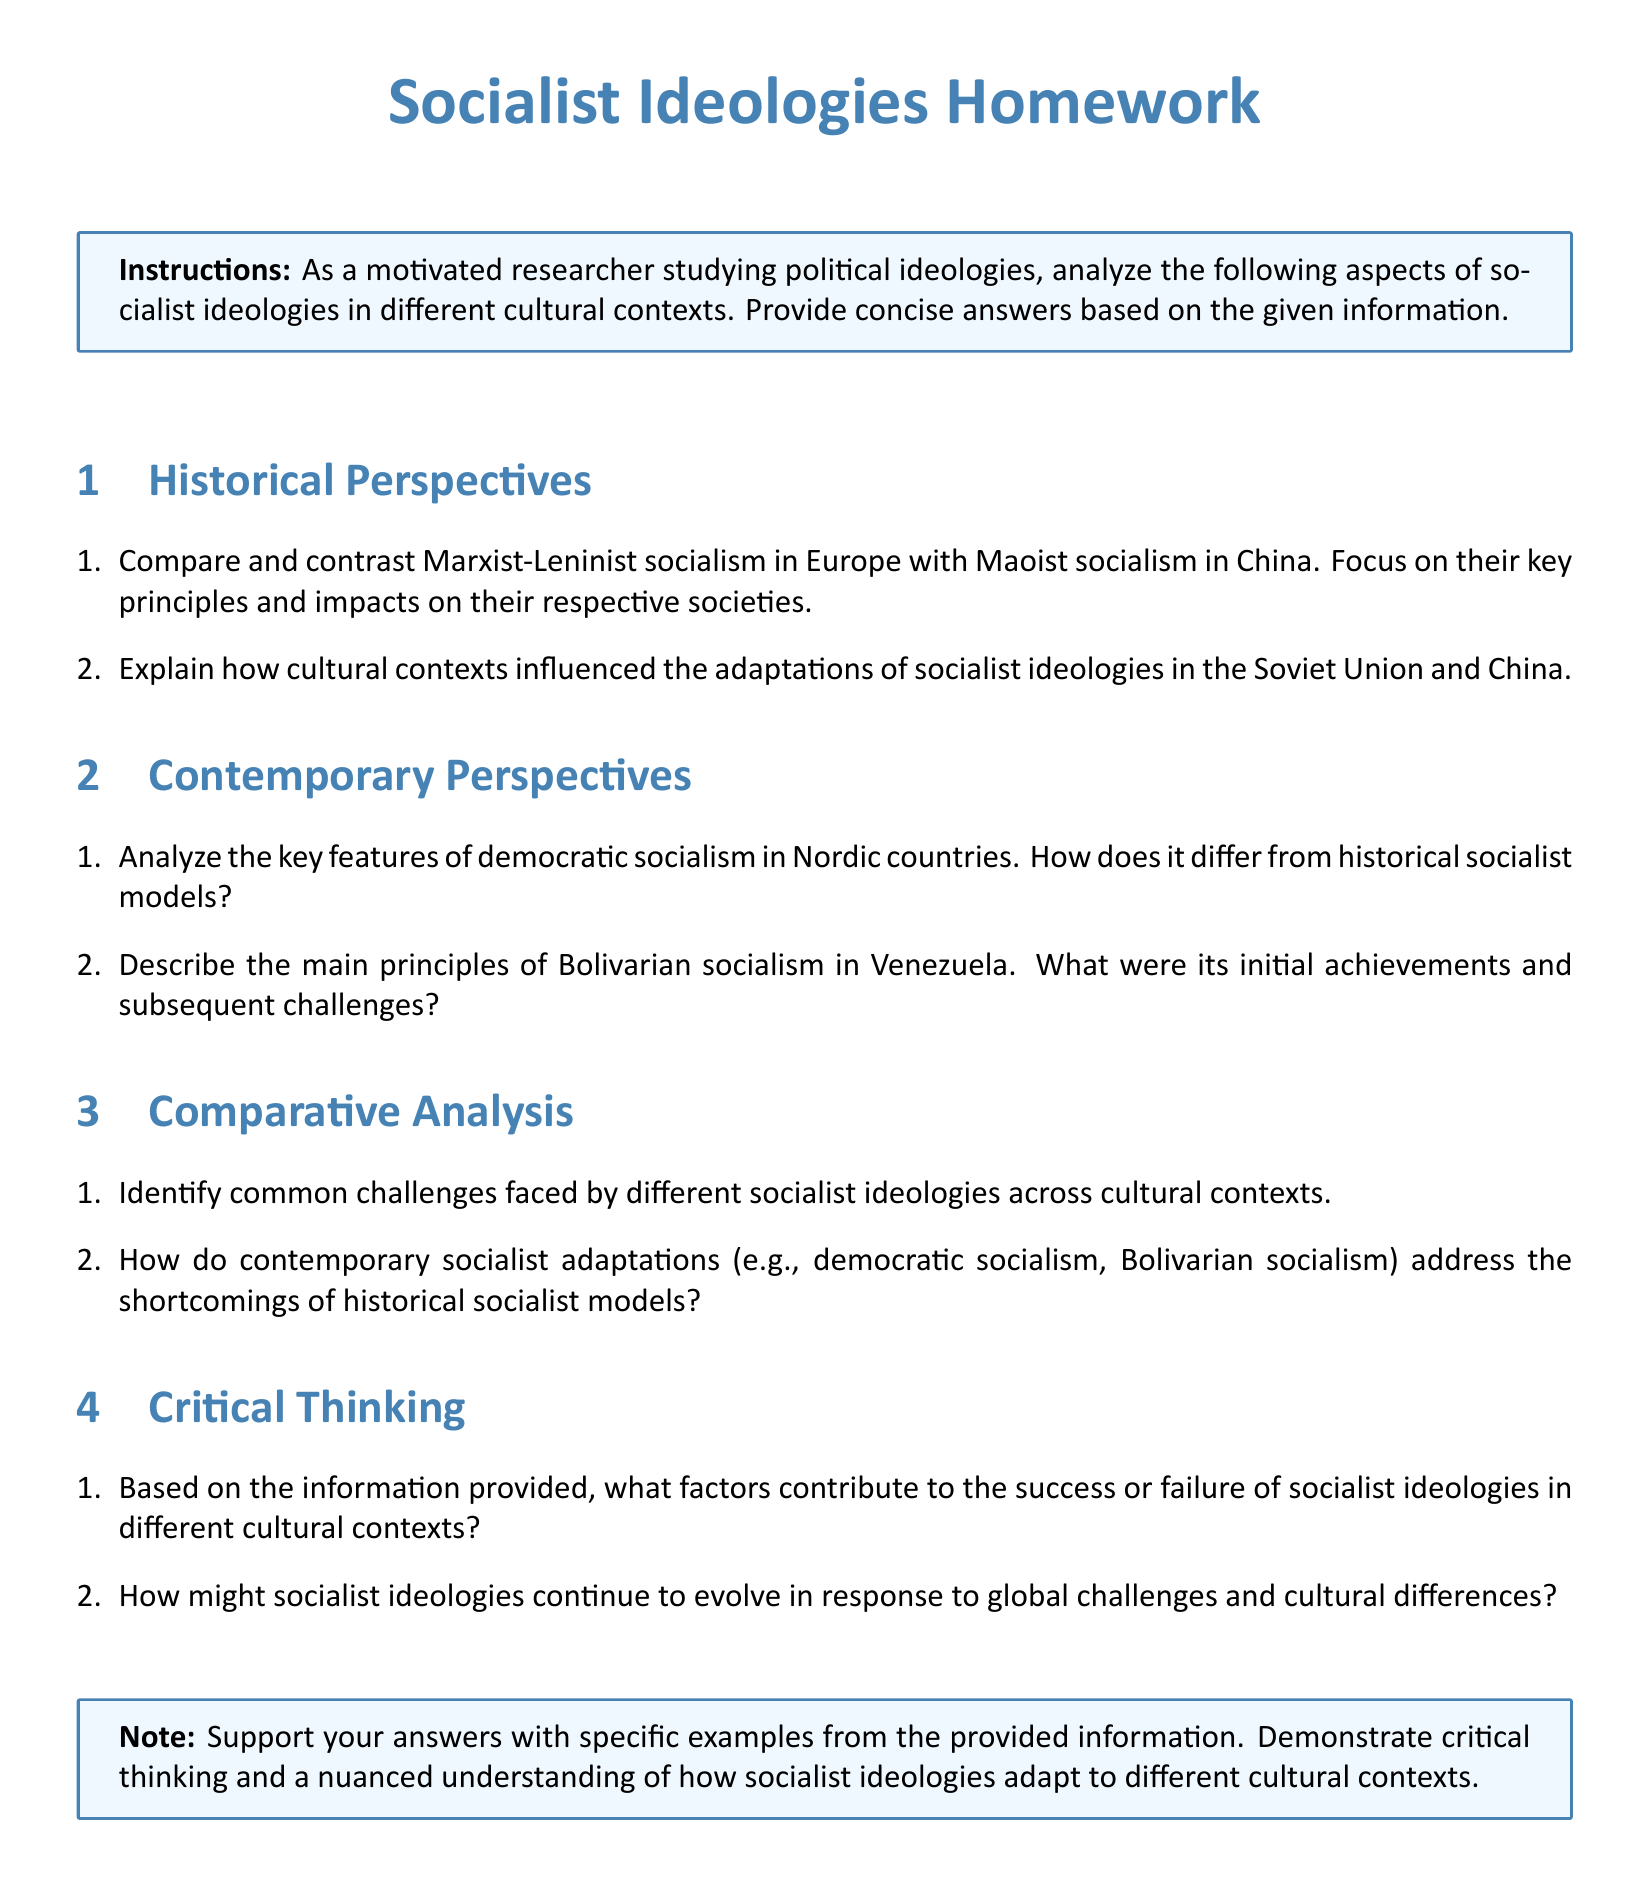What is the title of the homework? The title of the homework is presented at the top of the document.
Answer: Socialist Ideologies Homework How many sections are in the document? The document is organized into sections that are numbered.
Answer: Four What is the focus of the first question in the Historical Perspectives section? The first question asks for a comparison between two forms of socialism, which is detailed in the section.
Answer: Compare and contrast Marxist-Leninist socialism and Maoist socialism What are the main principles of Bolivarian socialism mentioned? This question relates to the description provided in the Contemporary Perspectives section.
Answer: Not explicitly stated; requires interpretation Which countries are associated with democratic socialism in the document? The document mentions specific countries in relation to contemporary socialist features.
Answer: Nordic countries What challenges do different socialist ideologies face? The question refers to the Comparative Analysis section, which discusses common issues.
Answer: Common challenges What kind of ideologies are evolving to respond to global challenges? The final questions focus on the future of socialist ideologies.
Answer: Socialist ideologies How many questions are in the Critical Thinking section? The section lists several inquiry-based questions related to analysis and reasoning.
Answer: Two 